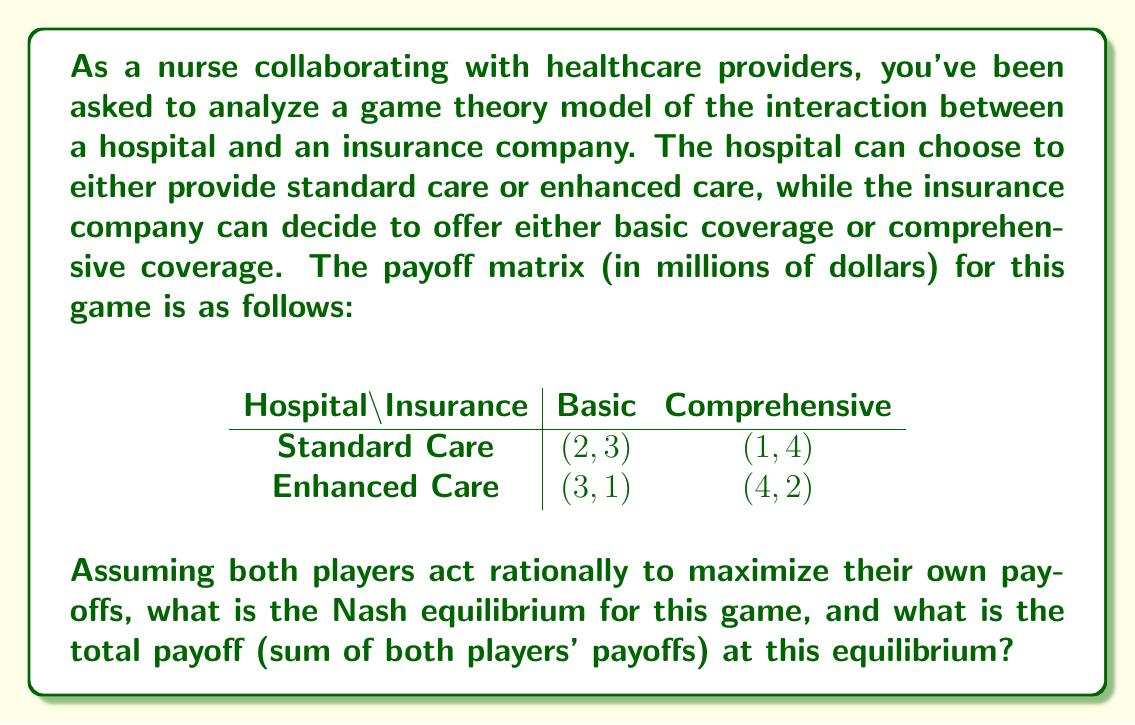Give your solution to this math problem. To solve this problem, we need to follow these steps:

1. Understand the payoff matrix:
   - The first number in each cell represents the hospital's payoff
   - The second number represents the insurance company's payoff

2. Find the best responses for each player:
   - For the hospital:
     - If insurance chooses Basic: Enhanced Care (3 > 2)
     - If insurance chooses Comprehensive: Enhanced Care (4 > 1)
   - For the insurance company:
     - If hospital chooses Standard Care: Comprehensive (4 > 3)
     - If hospital chooses Enhanced Care: Comprehensive (2 > 1)

3. Identify the Nash equilibrium:
   A Nash equilibrium occurs when both players are making their best response to the other player's strategy. In this case, we can see that (Enhanced Care, Comprehensive) is the Nash equilibrium because:
   - The hospital's best response to Comprehensive is Enhanced Care
   - The insurance company's best response to Enhanced Care is Comprehensive

4. Calculate the total payoff at the Nash equilibrium:
   - Hospital's payoff: 4
   - Insurance company's payoff: 2
   - Total payoff: 4 + 2 = 6

Therefore, the Nash equilibrium is (Enhanced Care, Comprehensive), and the total payoff at this equilibrium is 6 million dollars.
Answer: The Nash equilibrium is (Enhanced Care, Comprehensive), and the total payoff at this equilibrium is $6 million. 